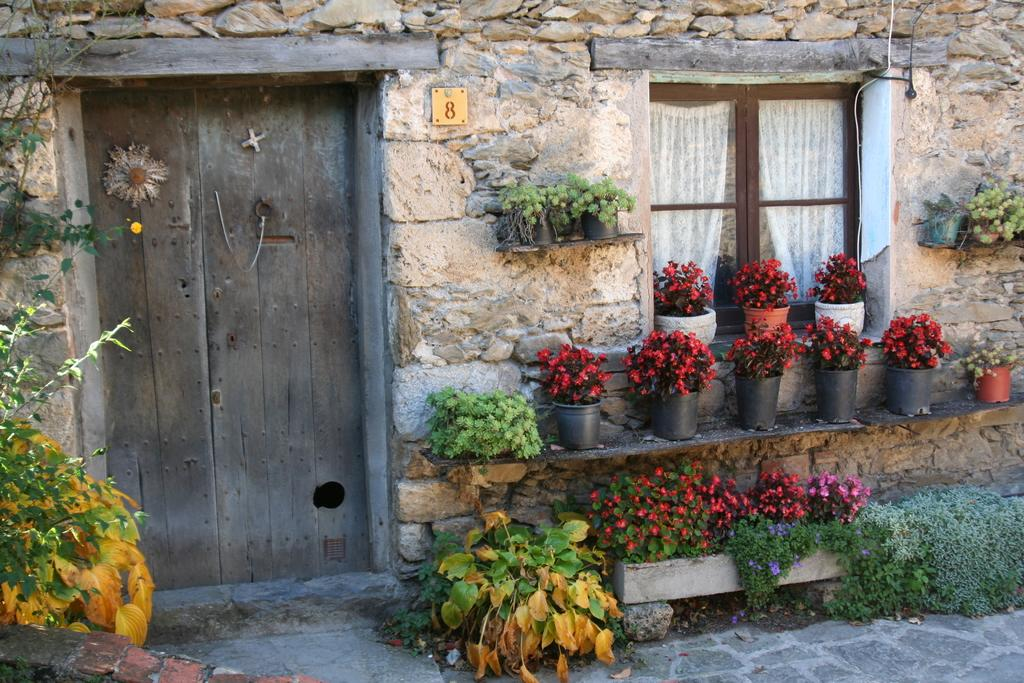What type of door is visible in the image? There is a wooden door in the image. What is located beside the wooden door? There is a wall beside the wooden door. What is situated beside the wall? There is a window beside the wall. What can be seen in front of the window? There are plants in front of the window. What type of yarn is being used to hold the window open in the image? There is no yarn present in the image, and the window is not being held open. Can you see any steam coming from the plants in front of the window? There is no steam visible in the image, and the plants are not producing steam. 